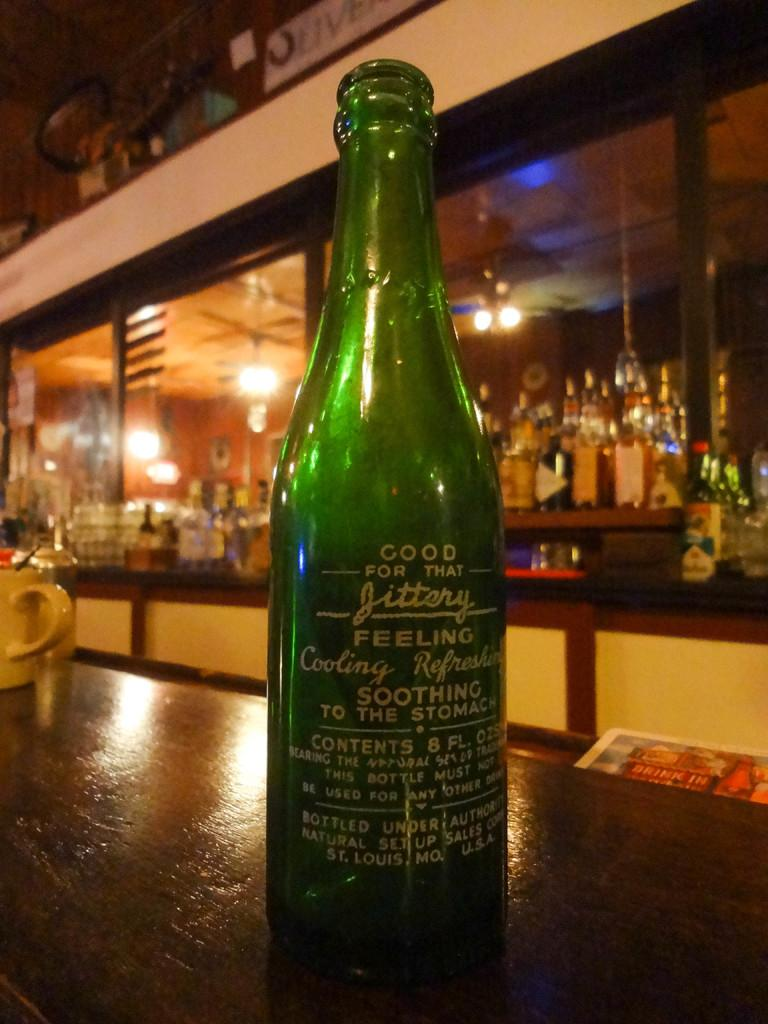<image>
Share a concise interpretation of the image provided. A green glass bottle of "Jittery" sits on a table near a bar. 